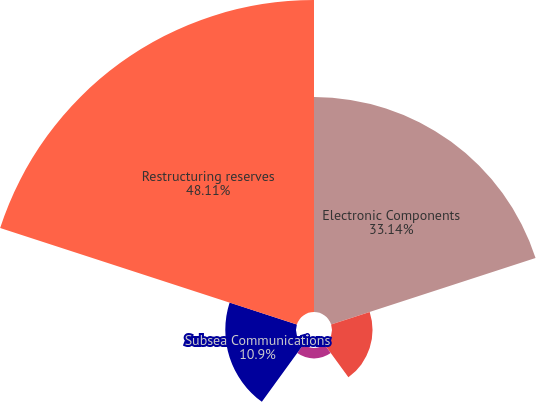Convert chart to OTSL. <chart><loc_0><loc_0><loc_500><loc_500><pie_chart><fcel>Electronic Components<fcel>Network Solutions<fcel>Specialty Products<fcel>Subsea Communications<fcel>Restructuring reserves<nl><fcel>33.14%<fcel>6.25%<fcel>1.6%<fcel>10.9%<fcel>48.1%<nl></chart> 